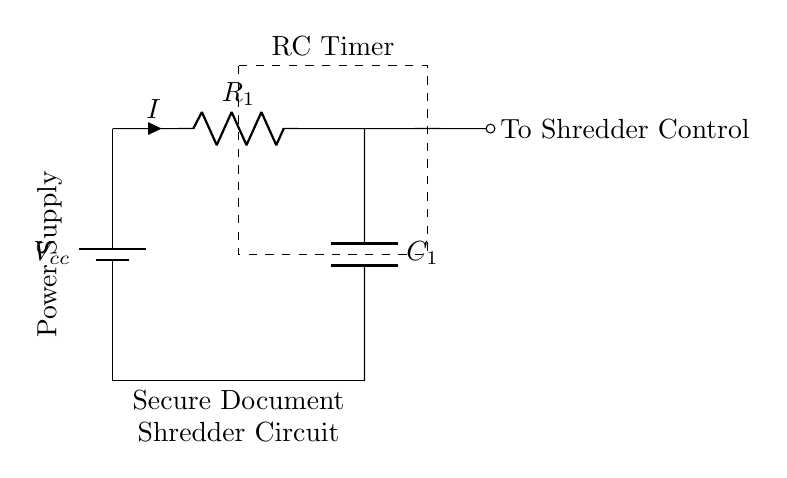What is the type of this circuit? This circuit is an RC timer circuit, which consists of a resistor and a capacitor used to control the timing operations of the shredder.
Answer: RC timer What is the value of the current through the resistor? The circuit indicates a current flowing through the resistor, denoted as I, but does not provide a numerical value. Therefore, without additional information about the voltage or resistance, we cannot determine an exact numeric answer for I from the diagram alone.
Answer: I What component is labeled C1? C1 in the diagram represents a capacitor, which is used in conjunction with the resistor to create the timing mechanism of the circuit.
Answer: Capacitor What is the purpose of the dashed rectangle in the diagram? The dashed rectangle highlights the area designated for the RC timer, indicating that this section of the circuit is responsible for the timing functions required to control the shredder operation.
Answer: RC Timer What type of control signal is indicated by the connection from C1? The connection from C1 leads to the shredder control, suggesting that this is the signal that activates or deactivates the shredder based on the timing provided by the RC circuit.
Answer: To Shredder Control What happens when the capacitor fully charges? When the capacitor fully charges, the voltage across it stabilizes, which ends the timing operation and potentially activates the shredder control circuit to initiate shredding.
Answer: Shredder activates 